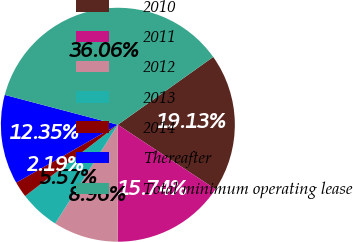Convert chart to OTSL. <chart><loc_0><loc_0><loc_500><loc_500><pie_chart><fcel>2010<fcel>2011<fcel>2012<fcel>2013<fcel>2014<fcel>Thereafter<fcel>Total minimum operating lease<nl><fcel>19.13%<fcel>15.74%<fcel>8.96%<fcel>5.57%<fcel>2.19%<fcel>12.35%<fcel>36.06%<nl></chart> 